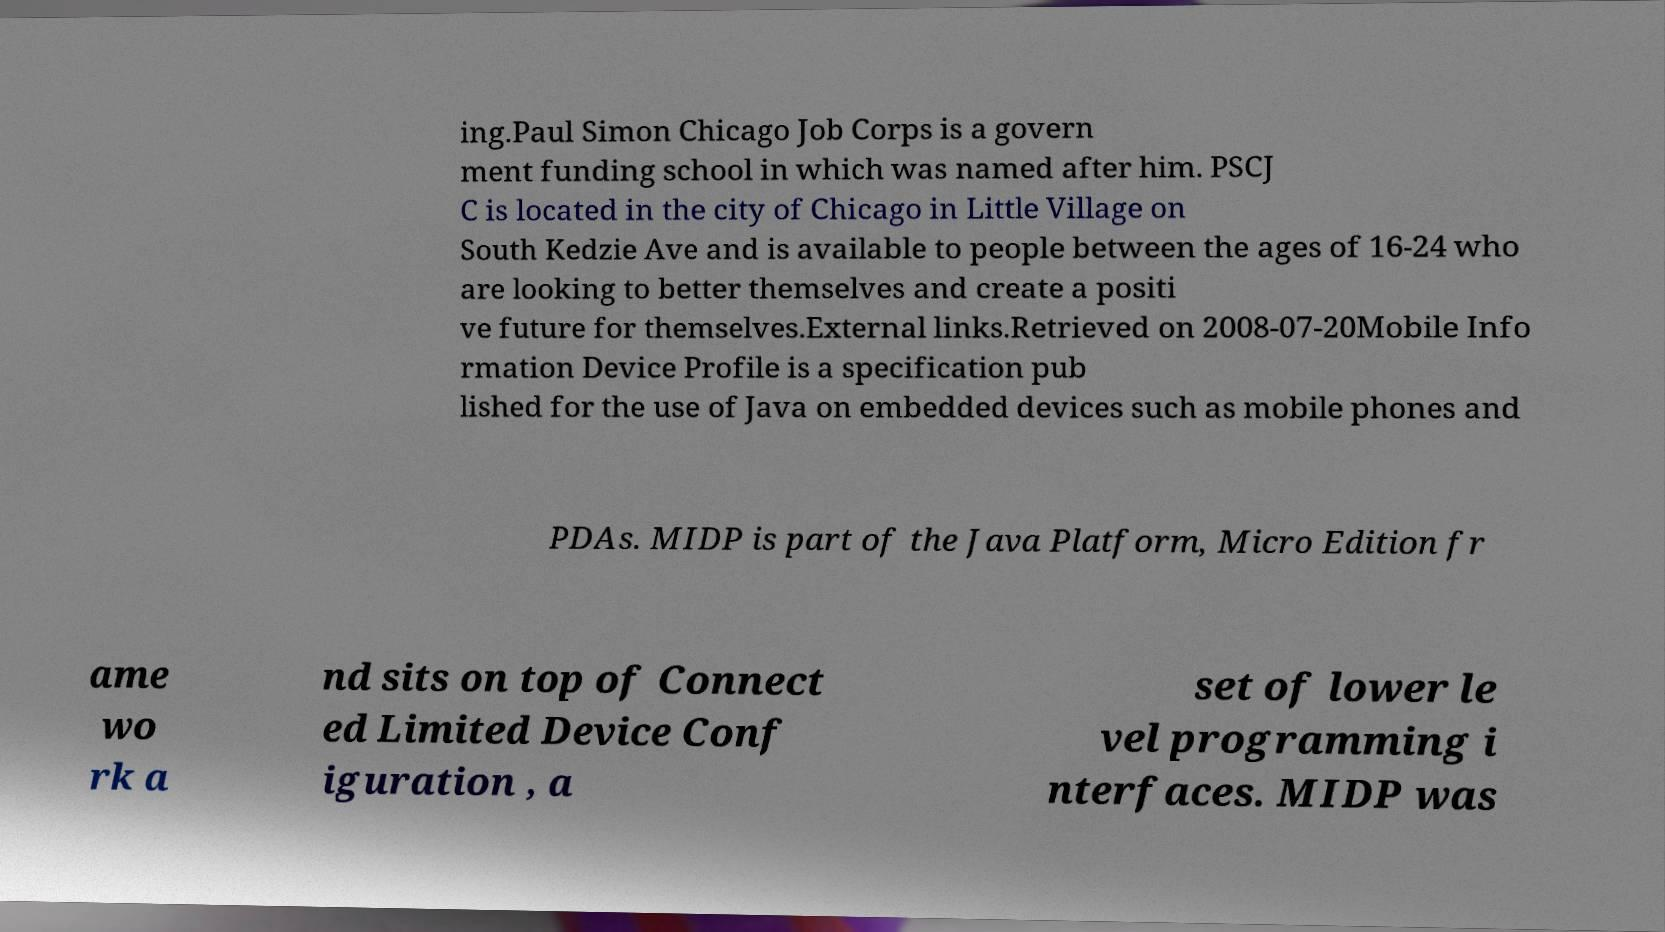I need the written content from this picture converted into text. Can you do that? ing.Paul Simon Chicago Job Corps is a govern ment funding school in which was named after him. PSCJ C is located in the city of Chicago in Little Village on South Kedzie Ave and is available to people between the ages of 16-24 who are looking to better themselves and create a positi ve future for themselves.External links.Retrieved on 2008-07-20Mobile Info rmation Device Profile is a specification pub lished for the use of Java on embedded devices such as mobile phones and PDAs. MIDP is part of the Java Platform, Micro Edition fr ame wo rk a nd sits on top of Connect ed Limited Device Conf iguration , a set of lower le vel programming i nterfaces. MIDP was 